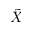Convert formula to latex. <formula><loc_0><loc_0><loc_500><loc_500>\tilde { X }</formula> 